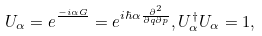<formula> <loc_0><loc_0><loc_500><loc_500>U _ { \alpha } = e ^ { \frac { - i \alpha G } { } } = e ^ { i \hbar { \alpha } \frac { \partial ^ { 2 } } { \partial q \partial p } } , U _ { \alpha } ^ { \dag } U _ { \alpha } = 1 ,</formula> 